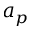<formula> <loc_0><loc_0><loc_500><loc_500>a _ { p }</formula> 